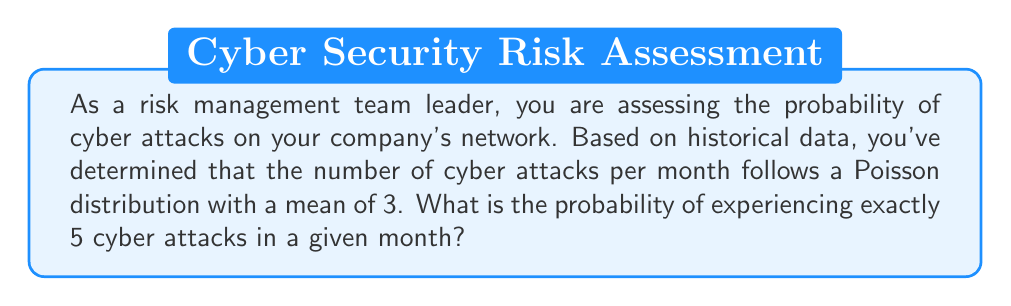Help me with this question. To solve this problem, we'll use the Poisson probability mass function:

$$P(X = k) = \frac{e^{-\lambda} \lambda^k}{k!}$$

Where:
$\lambda$ is the mean number of events in the given interval
$k$ is the number of events we're calculating the probability for
$e$ is Euler's number (approximately 2.71828)

Given:
$\lambda = 3$ (mean number of cyber attacks per month)
$k = 5$ (we're calculating the probability of exactly 5 attacks)

Let's substitute these values into the formula:

$$P(X = 5) = \frac{e^{-3} 3^5}{5!}$$

Now, let's calculate step by step:

1. Calculate $e^{-3}$:
   $e^{-3} \approx 0.0497871$

2. Calculate $3^5$:
   $3^5 = 243$

3. Calculate $5!$:
   $5! = 5 \times 4 \times 3 \times 2 \times 1 = 120$

4. Put it all together:
   $$P(X = 5) = \frac{0.0497871 \times 243}{120}$$

5. Perform the final calculation:
   $$P(X = 5) \approx 0.1008$$

Therefore, the probability of experiencing exactly 5 cyber attacks in a given month is approximately 0.1008 or 10.08%.
Answer: $P(X = 5) \approx 0.1008$ or $10.08\%$ 